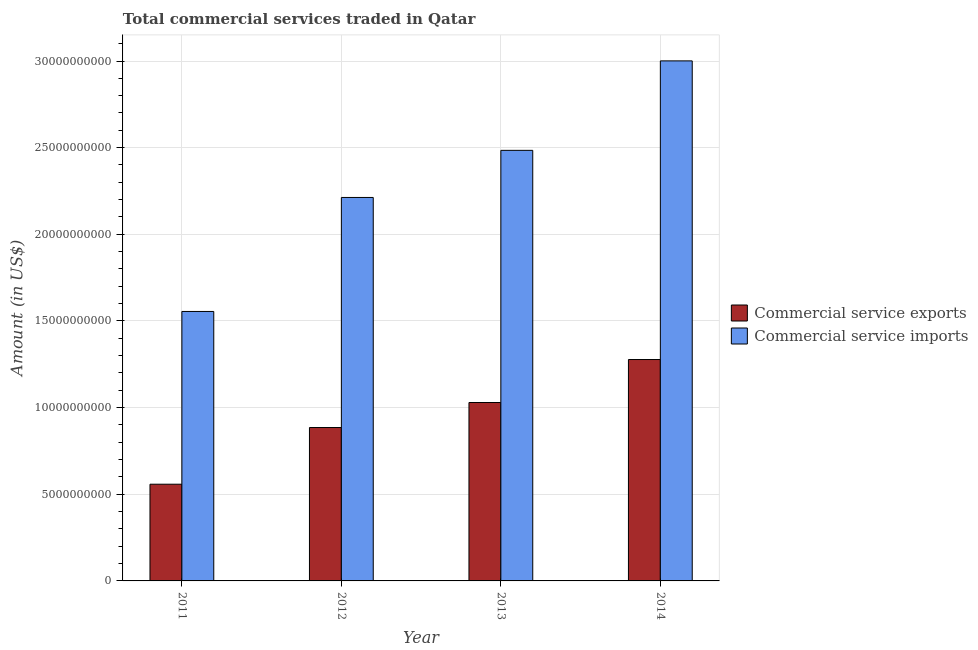How many different coloured bars are there?
Provide a short and direct response. 2. Are the number of bars per tick equal to the number of legend labels?
Keep it short and to the point. Yes. Are the number of bars on each tick of the X-axis equal?
Keep it short and to the point. Yes. How many bars are there on the 4th tick from the right?
Make the answer very short. 2. In how many cases, is the number of bars for a given year not equal to the number of legend labels?
Your response must be concise. 0. What is the amount of commercial service imports in 2011?
Keep it short and to the point. 1.55e+1. Across all years, what is the maximum amount of commercial service imports?
Offer a terse response. 3.00e+1. Across all years, what is the minimum amount of commercial service imports?
Your answer should be very brief. 1.55e+1. In which year was the amount of commercial service imports maximum?
Provide a succinct answer. 2014. In which year was the amount of commercial service imports minimum?
Offer a very short reply. 2011. What is the total amount of commercial service exports in the graph?
Make the answer very short. 3.75e+1. What is the difference between the amount of commercial service imports in 2012 and that in 2014?
Keep it short and to the point. -7.88e+09. What is the difference between the amount of commercial service imports in 2012 and the amount of commercial service exports in 2014?
Your answer should be compact. -7.88e+09. What is the average amount of commercial service exports per year?
Ensure brevity in your answer.  9.38e+09. In the year 2012, what is the difference between the amount of commercial service imports and amount of commercial service exports?
Provide a short and direct response. 0. What is the ratio of the amount of commercial service exports in 2013 to that in 2014?
Provide a short and direct response. 0.81. Is the amount of commercial service exports in 2012 less than that in 2014?
Your answer should be compact. Yes. What is the difference between the highest and the second highest amount of commercial service exports?
Provide a short and direct response. 2.48e+09. What is the difference between the highest and the lowest amount of commercial service exports?
Provide a succinct answer. 7.19e+09. In how many years, is the amount of commercial service imports greater than the average amount of commercial service imports taken over all years?
Give a very brief answer. 2. Is the sum of the amount of commercial service imports in 2012 and 2014 greater than the maximum amount of commercial service exports across all years?
Your response must be concise. Yes. What does the 1st bar from the left in 2014 represents?
Offer a terse response. Commercial service exports. What does the 2nd bar from the right in 2012 represents?
Offer a very short reply. Commercial service exports. Are all the bars in the graph horizontal?
Your response must be concise. No. How many years are there in the graph?
Your response must be concise. 4. Does the graph contain grids?
Provide a short and direct response. Yes. How many legend labels are there?
Ensure brevity in your answer.  2. What is the title of the graph?
Offer a very short reply. Total commercial services traded in Qatar. Does "Goods and services" appear as one of the legend labels in the graph?
Keep it short and to the point. No. What is the label or title of the Y-axis?
Provide a succinct answer. Amount (in US$). What is the Amount (in US$) of Commercial service exports in 2011?
Offer a terse response. 5.58e+09. What is the Amount (in US$) in Commercial service imports in 2011?
Make the answer very short. 1.55e+1. What is the Amount (in US$) of Commercial service exports in 2012?
Offer a terse response. 8.85e+09. What is the Amount (in US$) in Commercial service imports in 2012?
Give a very brief answer. 2.21e+1. What is the Amount (in US$) of Commercial service exports in 2013?
Provide a short and direct response. 1.03e+1. What is the Amount (in US$) in Commercial service imports in 2013?
Ensure brevity in your answer.  2.48e+1. What is the Amount (in US$) of Commercial service exports in 2014?
Offer a very short reply. 1.28e+1. What is the Amount (in US$) of Commercial service imports in 2014?
Ensure brevity in your answer.  3.00e+1. Across all years, what is the maximum Amount (in US$) in Commercial service exports?
Keep it short and to the point. 1.28e+1. Across all years, what is the maximum Amount (in US$) in Commercial service imports?
Your answer should be compact. 3.00e+1. Across all years, what is the minimum Amount (in US$) of Commercial service exports?
Your answer should be compact. 5.58e+09. Across all years, what is the minimum Amount (in US$) of Commercial service imports?
Provide a short and direct response. 1.55e+1. What is the total Amount (in US$) in Commercial service exports in the graph?
Your response must be concise. 3.75e+1. What is the total Amount (in US$) in Commercial service imports in the graph?
Give a very brief answer. 9.25e+1. What is the difference between the Amount (in US$) of Commercial service exports in 2011 and that in 2012?
Your answer should be very brief. -3.27e+09. What is the difference between the Amount (in US$) in Commercial service imports in 2011 and that in 2012?
Offer a terse response. -6.58e+09. What is the difference between the Amount (in US$) in Commercial service exports in 2011 and that in 2013?
Offer a terse response. -4.71e+09. What is the difference between the Amount (in US$) in Commercial service imports in 2011 and that in 2013?
Make the answer very short. -9.30e+09. What is the difference between the Amount (in US$) in Commercial service exports in 2011 and that in 2014?
Offer a terse response. -7.19e+09. What is the difference between the Amount (in US$) of Commercial service imports in 2011 and that in 2014?
Ensure brevity in your answer.  -1.45e+1. What is the difference between the Amount (in US$) of Commercial service exports in 2012 and that in 2013?
Your answer should be compact. -1.44e+09. What is the difference between the Amount (in US$) of Commercial service imports in 2012 and that in 2013?
Your response must be concise. -2.72e+09. What is the difference between the Amount (in US$) in Commercial service exports in 2012 and that in 2014?
Give a very brief answer. -3.92e+09. What is the difference between the Amount (in US$) of Commercial service imports in 2012 and that in 2014?
Ensure brevity in your answer.  -7.88e+09. What is the difference between the Amount (in US$) of Commercial service exports in 2013 and that in 2014?
Keep it short and to the point. -2.48e+09. What is the difference between the Amount (in US$) in Commercial service imports in 2013 and that in 2014?
Your response must be concise. -5.16e+09. What is the difference between the Amount (in US$) of Commercial service exports in 2011 and the Amount (in US$) of Commercial service imports in 2012?
Ensure brevity in your answer.  -1.65e+1. What is the difference between the Amount (in US$) in Commercial service exports in 2011 and the Amount (in US$) in Commercial service imports in 2013?
Make the answer very short. -1.93e+1. What is the difference between the Amount (in US$) in Commercial service exports in 2011 and the Amount (in US$) in Commercial service imports in 2014?
Keep it short and to the point. -2.44e+1. What is the difference between the Amount (in US$) of Commercial service exports in 2012 and the Amount (in US$) of Commercial service imports in 2013?
Provide a succinct answer. -1.60e+1. What is the difference between the Amount (in US$) in Commercial service exports in 2012 and the Amount (in US$) in Commercial service imports in 2014?
Offer a terse response. -2.12e+1. What is the difference between the Amount (in US$) of Commercial service exports in 2013 and the Amount (in US$) of Commercial service imports in 2014?
Give a very brief answer. -1.97e+1. What is the average Amount (in US$) of Commercial service exports per year?
Give a very brief answer. 9.38e+09. What is the average Amount (in US$) in Commercial service imports per year?
Offer a terse response. 2.31e+1. In the year 2011, what is the difference between the Amount (in US$) in Commercial service exports and Amount (in US$) in Commercial service imports?
Ensure brevity in your answer.  -9.97e+09. In the year 2012, what is the difference between the Amount (in US$) in Commercial service exports and Amount (in US$) in Commercial service imports?
Keep it short and to the point. -1.33e+1. In the year 2013, what is the difference between the Amount (in US$) of Commercial service exports and Amount (in US$) of Commercial service imports?
Keep it short and to the point. -1.45e+1. In the year 2014, what is the difference between the Amount (in US$) in Commercial service exports and Amount (in US$) in Commercial service imports?
Provide a succinct answer. -1.72e+1. What is the ratio of the Amount (in US$) in Commercial service exports in 2011 to that in 2012?
Your answer should be very brief. 0.63. What is the ratio of the Amount (in US$) of Commercial service imports in 2011 to that in 2012?
Offer a very short reply. 0.7. What is the ratio of the Amount (in US$) of Commercial service exports in 2011 to that in 2013?
Offer a very short reply. 0.54. What is the ratio of the Amount (in US$) of Commercial service imports in 2011 to that in 2013?
Offer a terse response. 0.63. What is the ratio of the Amount (in US$) of Commercial service exports in 2011 to that in 2014?
Your answer should be very brief. 0.44. What is the ratio of the Amount (in US$) in Commercial service imports in 2011 to that in 2014?
Offer a terse response. 0.52. What is the ratio of the Amount (in US$) in Commercial service exports in 2012 to that in 2013?
Your answer should be compact. 0.86. What is the ratio of the Amount (in US$) in Commercial service imports in 2012 to that in 2013?
Provide a succinct answer. 0.89. What is the ratio of the Amount (in US$) of Commercial service exports in 2012 to that in 2014?
Offer a terse response. 0.69. What is the ratio of the Amount (in US$) of Commercial service imports in 2012 to that in 2014?
Offer a very short reply. 0.74. What is the ratio of the Amount (in US$) of Commercial service exports in 2013 to that in 2014?
Make the answer very short. 0.81. What is the ratio of the Amount (in US$) in Commercial service imports in 2013 to that in 2014?
Your response must be concise. 0.83. What is the difference between the highest and the second highest Amount (in US$) of Commercial service exports?
Make the answer very short. 2.48e+09. What is the difference between the highest and the second highest Amount (in US$) in Commercial service imports?
Make the answer very short. 5.16e+09. What is the difference between the highest and the lowest Amount (in US$) of Commercial service exports?
Keep it short and to the point. 7.19e+09. What is the difference between the highest and the lowest Amount (in US$) in Commercial service imports?
Provide a short and direct response. 1.45e+1. 